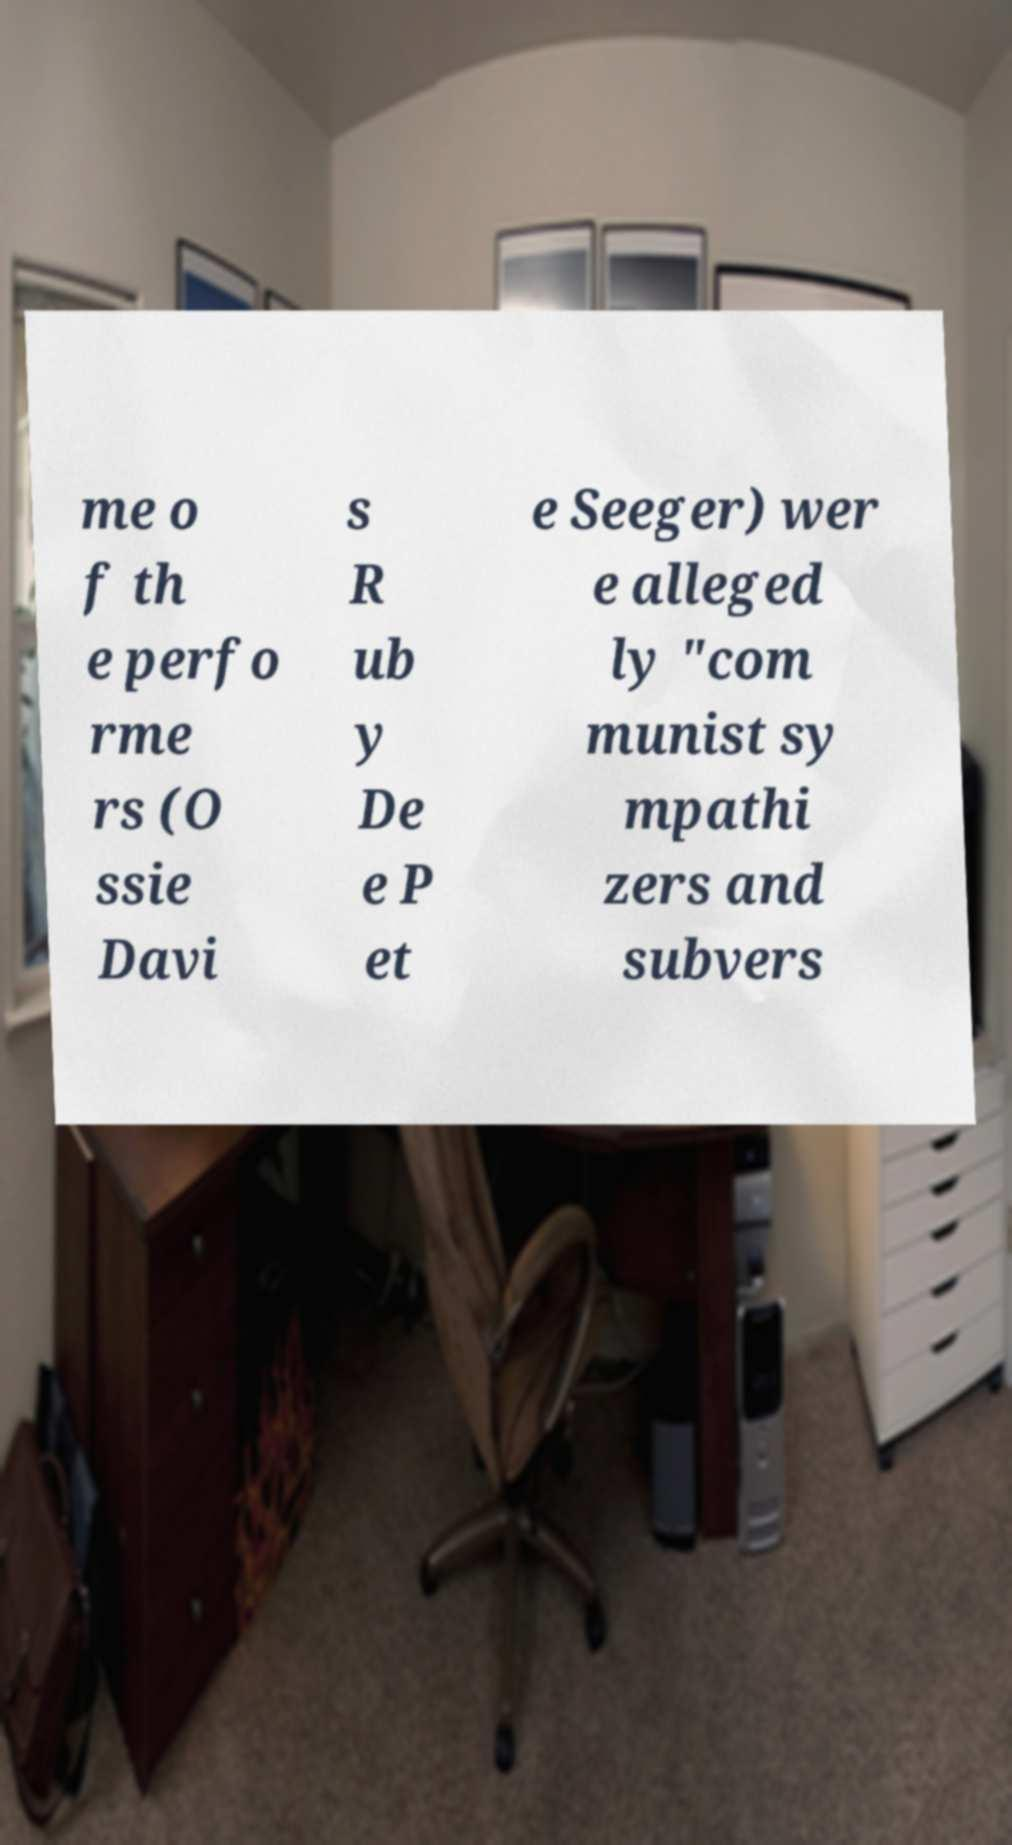Could you extract and type out the text from this image? The text on the image appears to talk about individuals associated with communism, though parts of the text are missing or obscured. The visible parts include: 'me o f th e perfo rme rs (O ssie Davi s R ub y De e P et e Seeger) wer e alleged ly "com munist sy mpathi zers and subvers"'. It discusses political affiliations and suspicions directed towards these performers. 